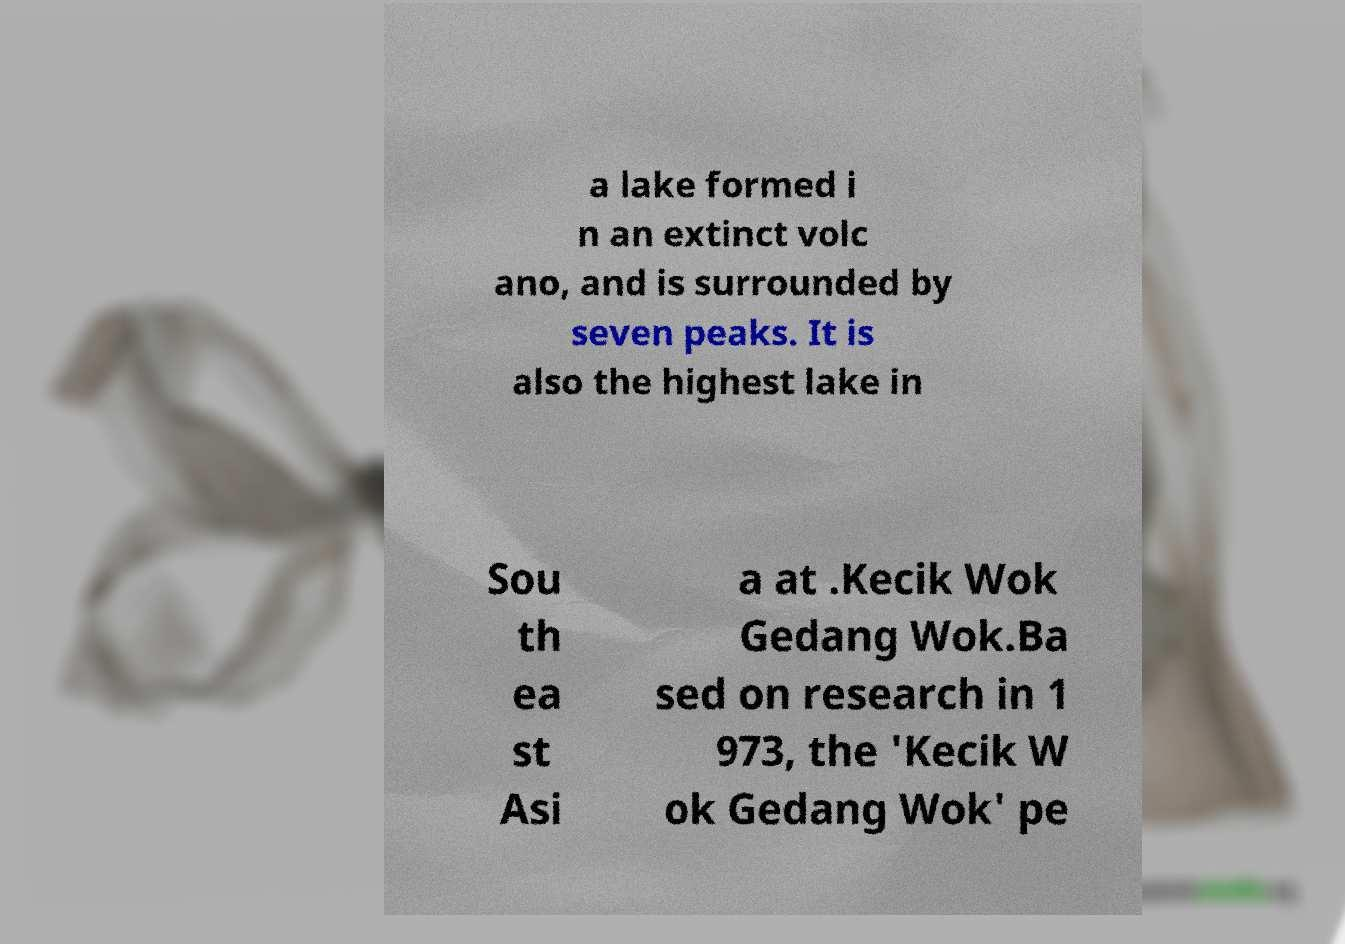Please read and relay the text visible in this image. What does it say? a lake formed i n an extinct volc ano, and is surrounded by seven peaks. It is also the highest lake in Sou th ea st Asi a at .Kecik Wok Gedang Wok.Ba sed on research in 1 973, the 'Kecik W ok Gedang Wok' pe 